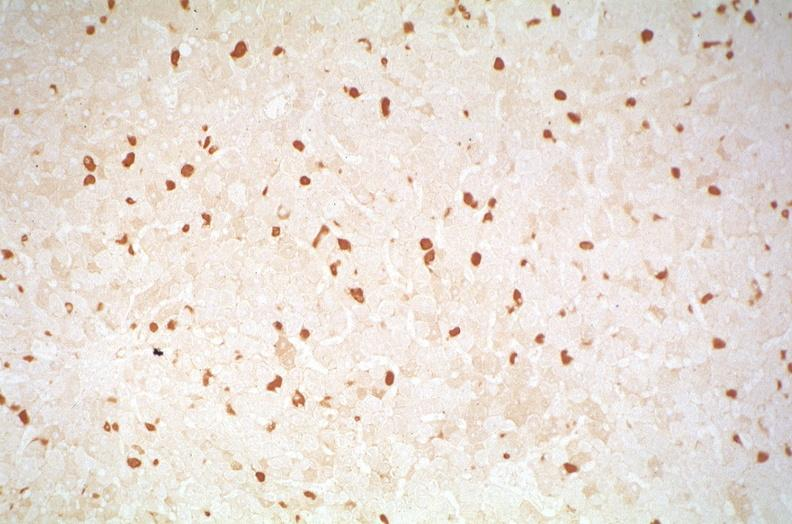what does this image show?
Answer the question using a single word or phrase. Hepatitis b virus 